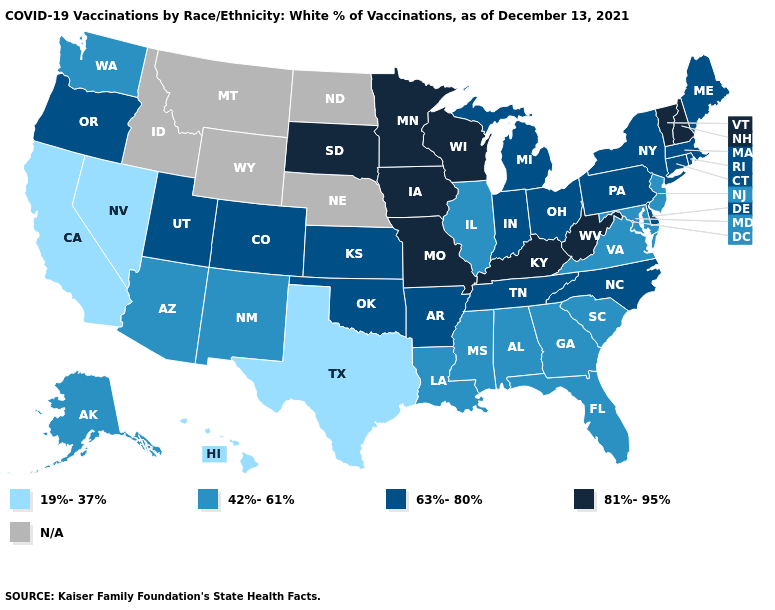Does Ohio have the highest value in the USA?
Answer briefly. No. Which states hav the highest value in the South?
Answer briefly. Kentucky, West Virginia. Which states have the lowest value in the MidWest?
Answer briefly. Illinois. Name the states that have a value in the range N/A?
Quick response, please. Idaho, Montana, Nebraska, North Dakota, Wyoming. Name the states that have a value in the range N/A?
Keep it brief. Idaho, Montana, Nebraska, North Dakota, Wyoming. What is the highest value in states that border Oregon?
Quick response, please. 42%-61%. What is the value of Oklahoma?
Keep it brief. 63%-80%. Name the states that have a value in the range 81%-95%?
Be succinct. Iowa, Kentucky, Minnesota, Missouri, New Hampshire, South Dakota, Vermont, West Virginia, Wisconsin. Name the states that have a value in the range N/A?
Be succinct. Idaho, Montana, Nebraska, North Dakota, Wyoming. Does Arizona have the highest value in the West?
Short answer required. No. What is the value of Kentucky?
Answer briefly. 81%-95%. Which states have the highest value in the USA?
Quick response, please. Iowa, Kentucky, Minnesota, Missouri, New Hampshire, South Dakota, Vermont, West Virginia, Wisconsin. Name the states that have a value in the range 63%-80%?
Quick response, please. Arkansas, Colorado, Connecticut, Delaware, Indiana, Kansas, Maine, Massachusetts, Michigan, New York, North Carolina, Ohio, Oklahoma, Oregon, Pennsylvania, Rhode Island, Tennessee, Utah. Name the states that have a value in the range 42%-61%?
Answer briefly. Alabama, Alaska, Arizona, Florida, Georgia, Illinois, Louisiana, Maryland, Mississippi, New Jersey, New Mexico, South Carolina, Virginia, Washington. Name the states that have a value in the range 19%-37%?
Short answer required. California, Hawaii, Nevada, Texas. 